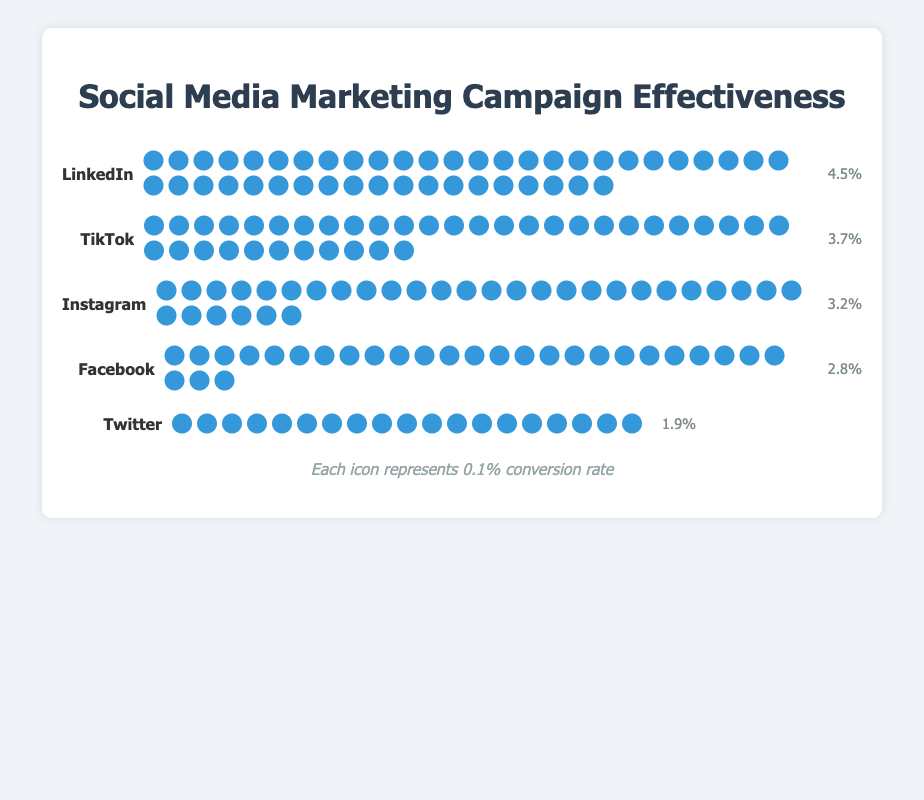What's the conversion rate for Facebook? The text next to the Facebook icon shows the conversion rate of 2.8%.
Answer: 2.8% How does the conversion rate of Instagram compare to Twitter? Instagram has a conversion rate of 3.2%, while Twitter's is 1.9%. Therefore, Instagram's conversion rate is higher than Twitter's.
Answer: Instagram's rate is higher Which platform has the highest conversion rate? By looking at the numbers, LinkedIn has the highest conversion rate of 4.5%.
Answer: LinkedIn How many icons are used to represent the conversion rate for TikTok? The icons next to the TikTok label add up to 37, with each representing 0.1%.
Answer: 37 What is the average conversion rate across all the platforms? Add up all the conversion rates (3.2% + 2.8% + 4.5% + 1.9% + 3.7%) = 16.1%. Divide by the number of platforms (5).
Answer: 3.22% What's the conversion rate difference between LinkedIn and Facebook? LinkedIn has a conversion rate of 4.5%, and Facebook has 2.8%. The difference is 4.5% - 2.8%.
Answer: 1.7% Rank the platforms from lowest to highest conversion rate. Based on the provided data, Twitter (1.9%), Facebook (2.8%), Instagram (3.2%), TikTok (3.7%), LinkedIn (4.5%).
Answer: Twitter, Facebook, Instagram, TikTok, LinkedIn How many icons does LinkedIn have more than Facebook? LinkedIn has 45 icons, and Facebook has 28 icons. The difference is 45 - 28.
Answer: 17 icons Which platform has the closest conversion rate to 3%? Instagram has a conversion rate of 3.2%, which is closest to 3%. TikTok is at 3.7%, slightly farther.
Answer: Instagram 